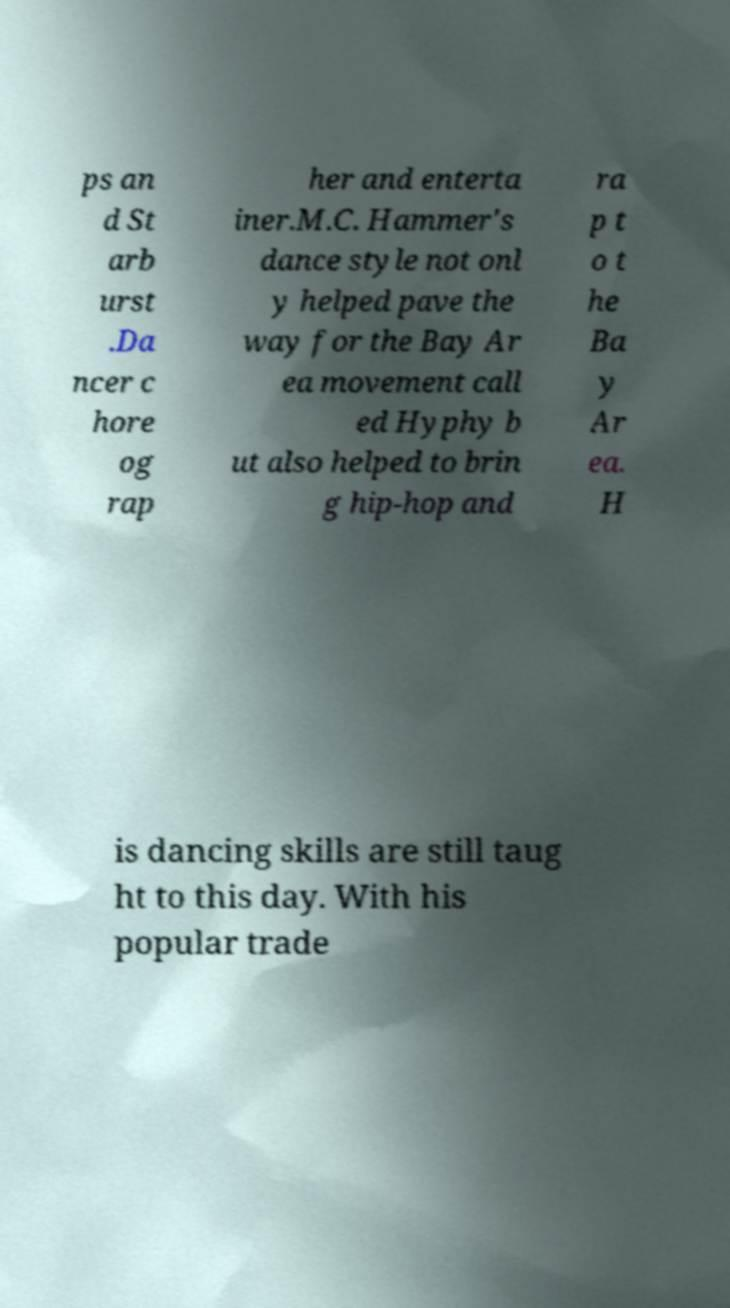For documentation purposes, I need the text within this image transcribed. Could you provide that? ps an d St arb urst .Da ncer c hore og rap her and enterta iner.M.C. Hammer's dance style not onl y helped pave the way for the Bay Ar ea movement call ed Hyphy b ut also helped to brin g hip-hop and ra p t o t he Ba y Ar ea. H is dancing skills are still taug ht to this day. With his popular trade 